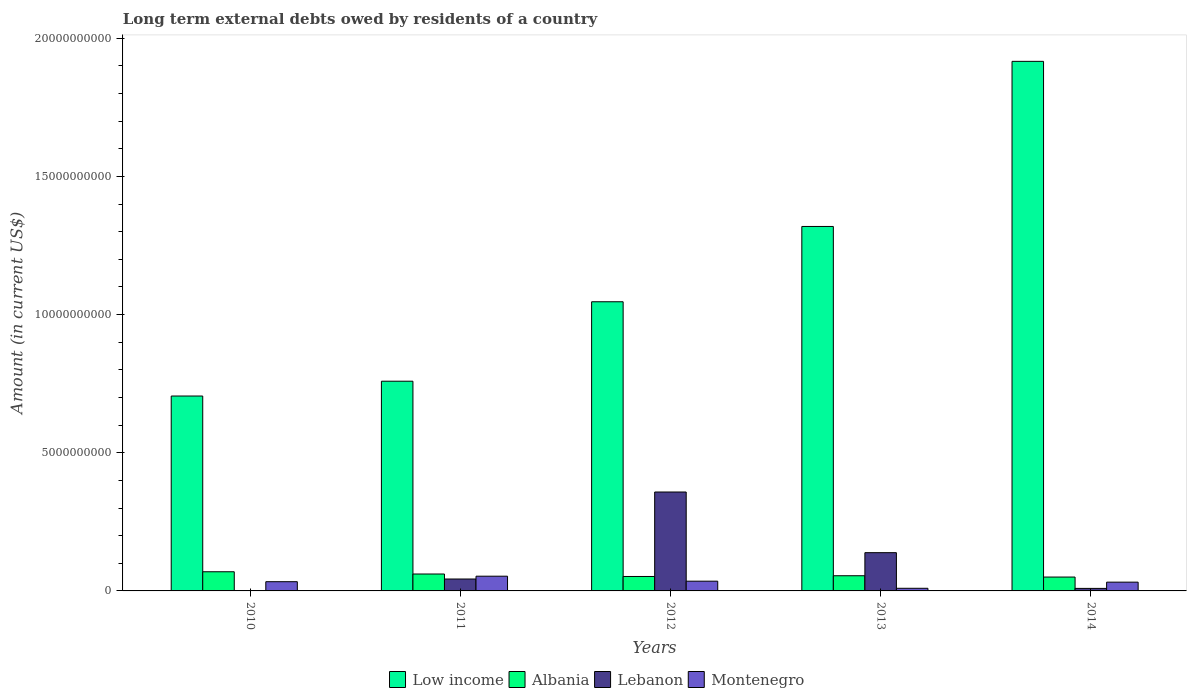How many groups of bars are there?
Provide a short and direct response. 5. How many bars are there on the 2nd tick from the right?
Give a very brief answer. 4. In how many cases, is the number of bars for a given year not equal to the number of legend labels?
Your response must be concise. 1. What is the amount of long-term external debts owed by residents in Albania in 2012?
Offer a terse response. 5.23e+08. Across all years, what is the maximum amount of long-term external debts owed by residents in Albania?
Make the answer very short. 6.93e+08. Across all years, what is the minimum amount of long-term external debts owed by residents in Montenegro?
Your response must be concise. 9.51e+07. In which year was the amount of long-term external debts owed by residents in Albania maximum?
Your answer should be compact. 2010. What is the total amount of long-term external debts owed by residents in Low income in the graph?
Offer a terse response. 5.75e+1. What is the difference between the amount of long-term external debts owed by residents in Albania in 2011 and that in 2013?
Ensure brevity in your answer.  6.29e+07. What is the difference between the amount of long-term external debts owed by residents in Low income in 2011 and the amount of long-term external debts owed by residents in Albania in 2013?
Your answer should be compact. 7.04e+09. What is the average amount of long-term external debts owed by residents in Montenegro per year?
Your response must be concise. 3.26e+08. In the year 2014, what is the difference between the amount of long-term external debts owed by residents in Low income and amount of long-term external debts owed by residents in Lebanon?
Provide a succinct answer. 1.91e+1. What is the ratio of the amount of long-term external debts owed by residents in Low income in 2010 to that in 2012?
Offer a very short reply. 0.67. Is the amount of long-term external debts owed by residents in Low income in 2011 less than that in 2014?
Give a very brief answer. Yes. Is the difference between the amount of long-term external debts owed by residents in Low income in 2011 and 2014 greater than the difference between the amount of long-term external debts owed by residents in Lebanon in 2011 and 2014?
Make the answer very short. No. What is the difference between the highest and the second highest amount of long-term external debts owed by residents in Low income?
Give a very brief answer. 5.97e+09. What is the difference between the highest and the lowest amount of long-term external debts owed by residents in Low income?
Provide a succinct answer. 1.21e+1. Is the sum of the amount of long-term external debts owed by residents in Albania in 2011 and 2013 greater than the maximum amount of long-term external debts owed by residents in Montenegro across all years?
Provide a short and direct response. Yes. Is it the case that in every year, the sum of the amount of long-term external debts owed by residents in Low income and amount of long-term external debts owed by residents in Lebanon is greater than the sum of amount of long-term external debts owed by residents in Albania and amount of long-term external debts owed by residents in Montenegro?
Ensure brevity in your answer.  Yes. Is it the case that in every year, the sum of the amount of long-term external debts owed by residents in Montenegro and amount of long-term external debts owed by residents in Albania is greater than the amount of long-term external debts owed by residents in Low income?
Your answer should be very brief. No. Are all the bars in the graph horizontal?
Offer a very short reply. No. What is the difference between two consecutive major ticks on the Y-axis?
Give a very brief answer. 5.00e+09. Does the graph contain any zero values?
Provide a succinct answer. Yes. Where does the legend appear in the graph?
Provide a short and direct response. Bottom center. How are the legend labels stacked?
Keep it short and to the point. Horizontal. What is the title of the graph?
Offer a terse response. Long term external debts owed by residents of a country. Does "Iran" appear as one of the legend labels in the graph?
Your answer should be compact. No. What is the label or title of the X-axis?
Provide a succinct answer. Years. What is the label or title of the Y-axis?
Your answer should be compact. Amount (in current US$). What is the Amount (in current US$) in Low income in 2010?
Provide a succinct answer. 7.05e+09. What is the Amount (in current US$) of Albania in 2010?
Give a very brief answer. 6.93e+08. What is the Amount (in current US$) of Montenegro in 2010?
Give a very brief answer. 3.34e+08. What is the Amount (in current US$) of Low income in 2011?
Offer a terse response. 7.59e+09. What is the Amount (in current US$) of Albania in 2011?
Offer a terse response. 6.12e+08. What is the Amount (in current US$) in Lebanon in 2011?
Your response must be concise. 4.31e+08. What is the Amount (in current US$) of Montenegro in 2011?
Give a very brief answer. 5.33e+08. What is the Amount (in current US$) of Low income in 2012?
Your response must be concise. 1.05e+1. What is the Amount (in current US$) of Albania in 2012?
Offer a terse response. 5.23e+08. What is the Amount (in current US$) of Lebanon in 2012?
Provide a succinct answer. 3.58e+09. What is the Amount (in current US$) in Montenegro in 2012?
Offer a terse response. 3.52e+08. What is the Amount (in current US$) in Low income in 2013?
Offer a very short reply. 1.32e+1. What is the Amount (in current US$) in Albania in 2013?
Your response must be concise. 5.49e+08. What is the Amount (in current US$) of Lebanon in 2013?
Your answer should be very brief. 1.38e+09. What is the Amount (in current US$) in Montenegro in 2013?
Your answer should be compact. 9.51e+07. What is the Amount (in current US$) in Low income in 2014?
Your answer should be very brief. 1.92e+1. What is the Amount (in current US$) of Albania in 2014?
Make the answer very short. 5.02e+08. What is the Amount (in current US$) in Lebanon in 2014?
Offer a terse response. 9.15e+07. What is the Amount (in current US$) in Montenegro in 2014?
Keep it short and to the point. 3.17e+08. Across all years, what is the maximum Amount (in current US$) of Low income?
Your answer should be compact. 1.92e+1. Across all years, what is the maximum Amount (in current US$) of Albania?
Make the answer very short. 6.93e+08. Across all years, what is the maximum Amount (in current US$) of Lebanon?
Offer a terse response. 3.58e+09. Across all years, what is the maximum Amount (in current US$) of Montenegro?
Your answer should be very brief. 5.33e+08. Across all years, what is the minimum Amount (in current US$) of Low income?
Ensure brevity in your answer.  7.05e+09. Across all years, what is the minimum Amount (in current US$) of Albania?
Ensure brevity in your answer.  5.02e+08. Across all years, what is the minimum Amount (in current US$) of Montenegro?
Your response must be concise. 9.51e+07. What is the total Amount (in current US$) of Low income in the graph?
Your answer should be compact. 5.75e+1. What is the total Amount (in current US$) in Albania in the graph?
Your answer should be compact. 2.88e+09. What is the total Amount (in current US$) in Lebanon in the graph?
Provide a succinct answer. 5.49e+09. What is the total Amount (in current US$) of Montenegro in the graph?
Ensure brevity in your answer.  1.63e+09. What is the difference between the Amount (in current US$) of Low income in 2010 and that in 2011?
Provide a succinct answer. -5.36e+08. What is the difference between the Amount (in current US$) of Albania in 2010 and that in 2011?
Make the answer very short. 8.15e+07. What is the difference between the Amount (in current US$) of Montenegro in 2010 and that in 2011?
Offer a terse response. -1.99e+08. What is the difference between the Amount (in current US$) of Low income in 2010 and that in 2012?
Your answer should be very brief. -3.41e+09. What is the difference between the Amount (in current US$) in Albania in 2010 and that in 2012?
Provide a succinct answer. 1.71e+08. What is the difference between the Amount (in current US$) of Montenegro in 2010 and that in 2012?
Keep it short and to the point. -1.85e+07. What is the difference between the Amount (in current US$) of Low income in 2010 and that in 2013?
Offer a very short reply. -6.14e+09. What is the difference between the Amount (in current US$) of Albania in 2010 and that in 2013?
Make the answer very short. 1.44e+08. What is the difference between the Amount (in current US$) in Montenegro in 2010 and that in 2013?
Make the answer very short. 2.39e+08. What is the difference between the Amount (in current US$) in Low income in 2010 and that in 2014?
Your answer should be compact. -1.21e+1. What is the difference between the Amount (in current US$) in Albania in 2010 and that in 2014?
Make the answer very short. 1.92e+08. What is the difference between the Amount (in current US$) in Montenegro in 2010 and that in 2014?
Provide a short and direct response. 1.67e+07. What is the difference between the Amount (in current US$) of Low income in 2011 and that in 2012?
Keep it short and to the point. -2.88e+09. What is the difference between the Amount (in current US$) in Albania in 2011 and that in 2012?
Offer a terse response. 8.91e+07. What is the difference between the Amount (in current US$) in Lebanon in 2011 and that in 2012?
Offer a terse response. -3.15e+09. What is the difference between the Amount (in current US$) in Montenegro in 2011 and that in 2012?
Give a very brief answer. 1.80e+08. What is the difference between the Amount (in current US$) of Low income in 2011 and that in 2013?
Your answer should be compact. -5.60e+09. What is the difference between the Amount (in current US$) in Albania in 2011 and that in 2013?
Give a very brief answer. 6.29e+07. What is the difference between the Amount (in current US$) in Lebanon in 2011 and that in 2013?
Provide a short and direct response. -9.53e+08. What is the difference between the Amount (in current US$) in Montenegro in 2011 and that in 2013?
Provide a short and direct response. 4.38e+08. What is the difference between the Amount (in current US$) in Low income in 2011 and that in 2014?
Your answer should be compact. -1.16e+1. What is the difference between the Amount (in current US$) of Albania in 2011 and that in 2014?
Keep it short and to the point. 1.10e+08. What is the difference between the Amount (in current US$) of Lebanon in 2011 and that in 2014?
Provide a succinct answer. 3.40e+08. What is the difference between the Amount (in current US$) of Montenegro in 2011 and that in 2014?
Make the answer very short. 2.16e+08. What is the difference between the Amount (in current US$) of Low income in 2012 and that in 2013?
Give a very brief answer. -2.72e+09. What is the difference between the Amount (in current US$) of Albania in 2012 and that in 2013?
Provide a short and direct response. -2.63e+07. What is the difference between the Amount (in current US$) in Lebanon in 2012 and that in 2013?
Offer a terse response. 2.20e+09. What is the difference between the Amount (in current US$) of Montenegro in 2012 and that in 2013?
Your answer should be compact. 2.57e+08. What is the difference between the Amount (in current US$) of Low income in 2012 and that in 2014?
Ensure brevity in your answer.  -8.70e+09. What is the difference between the Amount (in current US$) of Albania in 2012 and that in 2014?
Offer a very short reply. 2.08e+07. What is the difference between the Amount (in current US$) in Lebanon in 2012 and that in 2014?
Your answer should be compact. 3.49e+09. What is the difference between the Amount (in current US$) of Montenegro in 2012 and that in 2014?
Make the answer very short. 3.52e+07. What is the difference between the Amount (in current US$) in Low income in 2013 and that in 2014?
Your answer should be very brief. -5.97e+09. What is the difference between the Amount (in current US$) of Albania in 2013 and that in 2014?
Your answer should be very brief. 4.71e+07. What is the difference between the Amount (in current US$) in Lebanon in 2013 and that in 2014?
Keep it short and to the point. 1.29e+09. What is the difference between the Amount (in current US$) in Montenegro in 2013 and that in 2014?
Give a very brief answer. -2.22e+08. What is the difference between the Amount (in current US$) in Low income in 2010 and the Amount (in current US$) in Albania in 2011?
Your answer should be compact. 6.44e+09. What is the difference between the Amount (in current US$) of Low income in 2010 and the Amount (in current US$) of Lebanon in 2011?
Give a very brief answer. 6.62e+09. What is the difference between the Amount (in current US$) in Low income in 2010 and the Amount (in current US$) in Montenegro in 2011?
Your answer should be compact. 6.52e+09. What is the difference between the Amount (in current US$) of Albania in 2010 and the Amount (in current US$) of Lebanon in 2011?
Ensure brevity in your answer.  2.62e+08. What is the difference between the Amount (in current US$) in Albania in 2010 and the Amount (in current US$) in Montenegro in 2011?
Provide a short and direct response. 1.61e+08. What is the difference between the Amount (in current US$) of Low income in 2010 and the Amount (in current US$) of Albania in 2012?
Offer a very short reply. 6.53e+09. What is the difference between the Amount (in current US$) in Low income in 2010 and the Amount (in current US$) in Lebanon in 2012?
Your answer should be very brief. 3.47e+09. What is the difference between the Amount (in current US$) of Low income in 2010 and the Amount (in current US$) of Montenegro in 2012?
Keep it short and to the point. 6.70e+09. What is the difference between the Amount (in current US$) of Albania in 2010 and the Amount (in current US$) of Lebanon in 2012?
Offer a very short reply. -2.89e+09. What is the difference between the Amount (in current US$) of Albania in 2010 and the Amount (in current US$) of Montenegro in 2012?
Keep it short and to the point. 3.41e+08. What is the difference between the Amount (in current US$) of Low income in 2010 and the Amount (in current US$) of Albania in 2013?
Make the answer very short. 6.50e+09. What is the difference between the Amount (in current US$) in Low income in 2010 and the Amount (in current US$) in Lebanon in 2013?
Your response must be concise. 5.67e+09. What is the difference between the Amount (in current US$) of Low income in 2010 and the Amount (in current US$) of Montenegro in 2013?
Keep it short and to the point. 6.96e+09. What is the difference between the Amount (in current US$) of Albania in 2010 and the Amount (in current US$) of Lebanon in 2013?
Provide a short and direct response. -6.91e+08. What is the difference between the Amount (in current US$) in Albania in 2010 and the Amount (in current US$) in Montenegro in 2013?
Your answer should be compact. 5.98e+08. What is the difference between the Amount (in current US$) of Low income in 2010 and the Amount (in current US$) of Albania in 2014?
Offer a terse response. 6.55e+09. What is the difference between the Amount (in current US$) of Low income in 2010 and the Amount (in current US$) of Lebanon in 2014?
Provide a short and direct response. 6.96e+09. What is the difference between the Amount (in current US$) in Low income in 2010 and the Amount (in current US$) in Montenegro in 2014?
Give a very brief answer. 6.73e+09. What is the difference between the Amount (in current US$) in Albania in 2010 and the Amount (in current US$) in Lebanon in 2014?
Offer a very short reply. 6.02e+08. What is the difference between the Amount (in current US$) in Albania in 2010 and the Amount (in current US$) in Montenegro in 2014?
Offer a very short reply. 3.76e+08. What is the difference between the Amount (in current US$) in Low income in 2011 and the Amount (in current US$) in Albania in 2012?
Give a very brief answer. 7.07e+09. What is the difference between the Amount (in current US$) of Low income in 2011 and the Amount (in current US$) of Lebanon in 2012?
Keep it short and to the point. 4.01e+09. What is the difference between the Amount (in current US$) in Low income in 2011 and the Amount (in current US$) in Montenegro in 2012?
Give a very brief answer. 7.24e+09. What is the difference between the Amount (in current US$) of Albania in 2011 and the Amount (in current US$) of Lebanon in 2012?
Your response must be concise. -2.97e+09. What is the difference between the Amount (in current US$) in Albania in 2011 and the Amount (in current US$) in Montenegro in 2012?
Give a very brief answer. 2.59e+08. What is the difference between the Amount (in current US$) of Lebanon in 2011 and the Amount (in current US$) of Montenegro in 2012?
Your answer should be compact. 7.88e+07. What is the difference between the Amount (in current US$) of Low income in 2011 and the Amount (in current US$) of Albania in 2013?
Your answer should be very brief. 7.04e+09. What is the difference between the Amount (in current US$) of Low income in 2011 and the Amount (in current US$) of Lebanon in 2013?
Your answer should be compact. 6.20e+09. What is the difference between the Amount (in current US$) of Low income in 2011 and the Amount (in current US$) of Montenegro in 2013?
Your answer should be compact. 7.49e+09. What is the difference between the Amount (in current US$) of Albania in 2011 and the Amount (in current US$) of Lebanon in 2013?
Your answer should be compact. -7.72e+08. What is the difference between the Amount (in current US$) in Albania in 2011 and the Amount (in current US$) in Montenegro in 2013?
Your answer should be very brief. 5.17e+08. What is the difference between the Amount (in current US$) of Lebanon in 2011 and the Amount (in current US$) of Montenegro in 2013?
Provide a succinct answer. 3.36e+08. What is the difference between the Amount (in current US$) of Low income in 2011 and the Amount (in current US$) of Albania in 2014?
Ensure brevity in your answer.  7.09e+09. What is the difference between the Amount (in current US$) of Low income in 2011 and the Amount (in current US$) of Lebanon in 2014?
Keep it short and to the point. 7.50e+09. What is the difference between the Amount (in current US$) of Low income in 2011 and the Amount (in current US$) of Montenegro in 2014?
Offer a terse response. 7.27e+09. What is the difference between the Amount (in current US$) in Albania in 2011 and the Amount (in current US$) in Lebanon in 2014?
Your answer should be compact. 5.20e+08. What is the difference between the Amount (in current US$) in Albania in 2011 and the Amount (in current US$) in Montenegro in 2014?
Provide a short and direct response. 2.95e+08. What is the difference between the Amount (in current US$) in Lebanon in 2011 and the Amount (in current US$) in Montenegro in 2014?
Your answer should be very brief. 1.14e+08. What is the difference between the Amount (in current US$) in Low income in 2012 and the Amount (in current US$) in Albania in 2013?
Offer a very short reply. 9.91e+09. What is the difference between the Amount (in current US$) of Low income in 2012 and the Amount (in current US$) of Lebanon in 2013?
Keep it short and to the point. 9.08e+09. What is the difference between the Amount (in current US$) of Low income in 2012 and the Amount (in current US$) of Montenegro in 2013?
Offer a terse response. 1.04e+1. What is the difference between the Amount (in current US$) of Albania in 2012 and the Amount (in current US$) of Lebanon in 2013?
Make the answer very short. -8.61e+08. What is the difference between the Amount (in current US$) in Albania in 2012 and the Amount (in current US$) in Montenegro in 2013?
Provide a succinct answer. 4.28e+08. What is the difference between the Amount (in current US$) in Lebanon in 2012 and the Amount (in current US$) in Montenegro in 2013?
Provide a succinct answer. 3.48e+09. What is the difference between the Amount (in current US$) in Low income in 2012 and the Amount (in current US$) in Albania in 2014?
Ensure brevity in your answer.  9.96e+09. What is the difference between the Amount (in current US$) of Low income in 2012 and the Amount (in current US$) of Lebanon in 2014?
Ensure brevity in your answer.  1.04e+1. What is the difference between the Amount (in current US$) in Low income in 2012 and the Amount (in current US$) in Montenegro in 2014?
Provide a succinct answer. 1.01e+1. What is the difference between the Amount (in current US$) in Albania in 2012 and the Amount (in current US$) in Lebanon in 2014?
Offer a terse response. 4.31e+08. What is the difference between the Amount (in current US$) of Albania in 2012 and the Amount (in current US$) of Montenegro in 2014?
Offer a terse response. 2.06e+08. What is the difference between the Amount (in current US$) in Lebanon in 2012 and the Amount (in current US$) in Montenegro in 2014?
Provide a short and direct response. 3.26e+09. What is the difference between the Amount (in current US$) in Low income in 2013 and the Amount (in current US$) in Albania in 2014?
Give a very brief answer. 1.27e+1. What is the difference between the Amount (in current US$) of Low income in 2013 and the Amount (in current US$) of Lebanon in 2014?
Offer a terse response. 1.31e+1. What is the difference between the Amount (in current US$) of Low income in 2013 and the Amount (in current US$) of Montenegro in 2014?
Make the answer very short. 1.29e+1. What is the difference between the Amount (in current US$) in Albania in 2013 and the Amount (in current US$) in Lebanon in 2014?
Give a very brief answer. 4.58e+08. What is the difference between the Amount (in current US$) of Albania in 2013 and the Amount (in current US$) of Montenegro in 2014?
Your response must be concise. 2.32e+08. What is the difference between the Amount (in current US$) in Lebanon in 2013 and the Amount (in current US$) in Montenegro in 2014?
Your answer should be very brief. 1.07e+09. What is the average Amount (in current US$) of Low income per year?
Ensure brevity in your answer.  1.15e+1. What is the average Amount (in current US$) in Albania per year?
Ensure brevity in your answer.  5.76e+08. What is the average Amount (in current US$) of Lebanon per year?
Your answer should be compact. 1.10e+09. What is the average Amount (in current US$) of Montenegro per year?
Offer a very short reply. 3.26e+08. In the year 2010, what is the difference between the Amount (in current US$) of Low income and Amount (in current US$) of Albania?
Make the answer very short. 6.36e+09. In the year 2010, what is the difference between the Amount (in current US$) of Low income and Amount (in current US$) of Montenegro?
Provide a succinct answer. 6.72e+09. In the year 2010, what is the difference between the Amount (in current US$) in Albania and Amount (in current US$) in Montenegro?
Ensure brevity in your answer.  3.59e+08. In the year 2011, what is the difference between the Amount (in current US$) in Low income and Amount (in current US$) in Albania?
Keep it short and to the point. 6.98e+09. In the year 2011, what is the difference between the Amount (in current US$) in Low income and Amount (in current US$) in Lebanon?
Make the answer very short. 7.16e+09. In the year 2011, what is the difference between the Amount (in current US$) of Low income and Amount (in current US$) of Montenegro?
Keep it short and to the point. 7.06e+09. In the year 2011, what is the difference between the Amount (in current US$) of Albania and Amount (in current US$) of Lebanon?
Provide a short and direct response. 1.81e+08. In the year 2011, what is the difference between the Amount (in current US$) in Albania and Amount (in current US$) in Montenegro?
Offer a very short reply. 7.91e+07. In the year 2011, what is the difference between the Amount (in current US$) of Lebanon and Amount (in current US$) of Montenegro?
Your response must be concise. -1.02e+08. In the year 2012, what is the difference between the Amount (in current US$) of Low income and Amount (in current US$) of Albania?
Your response must be concise. 9.94e+09. In the year 2012, what is the difference between the Amount (in current US$) of Low income and Amount (in current US$) of Lebanon?
Keep it short and to the point. 6.88e+09. In the year 2012, what is the difference between the Amount (in current US$) of Low income and Amount (in current US$) of Montenegro?
Give a very brief answer. 1.01e+1. In the year 2012, what is the difference between the Amount (in current US$) in Albania and Amount (in current US$) in Lebanon?
Offer a terse response. -3.06e+09. In the year 2012, what is the difference between the Amount (in current US$) in Albania and Amount (in current US$) in Montenegro?
Your answer should be compact. 1.70e+08. In the year 2012, what is the difference between the Amount (in current US$) of Lebanon and Amount (in current US$) of Montenegro?
Give a very brief answer. 3.23e+09. In the year 2013, what is the difference between the Amount (in current US$) in Low income and Amount (in current US$) in Albania?
Your response must be concise. 1.26e+1. In the year 2013, what is the difference between the Amount (in current US$) of Low income and Amount (in current US$) of Lebanon?
Make the answer very short. 1.18e+1. In the year 2013, what is the difference between the Amount (in current US$) in Low income and Amount (in current US$) in Montenegro?
Your response must be concise. 1.31e+1. In the year 2013, what is the difference between the Amount (in current US$) in Albania and Amount (in current US$) in Lebanon?
Ensure brevity in your answer.  -8.35e+08. In the year 2013, what is the difference between the Amount (in current US$) in Albania and Amount (in current US$) in Montenegro?
Your answer should be compact. 4.54e+08. In the year 2013, what is the difference between the Amount (in current US$) in Lebanon and Amount (in current US$) in Montenegro?
Ensure brevity in your answer.  1.29e+09. In the year 2014, what is the difference between the Amount (in current US$) of Low income and Amount (in current US$) of Albania?
Provide a succinct answer. 1.87e+1. In the year 2014, what is the difference between the Amount (in current US$) in Low income and Amount (in current US$) in Lebanon?
Offer a very short reply. 1.91e+1. In the year 2014, what is the difference between the Amount (in current US$) of Low income and Amount (in current US$) of Montenegro?
Provide a short and direct response. 1.88e+1. In the year 2014, what is the difference between the Amount (in current US$) in Albania and Amount (in current US$) in Lebanon?
Make the answer very short. 4.10e+08. In the year 2014, what is the difference between the Amount (in current US$) in Albania and Amount (in current US$) in Montenegro?
Ensure brevity in your answer.  1.85e+08. In the year 2014, what is the difference between the Amount (in current US$) in Lebanon and Amount (in current US$) in Montenegro?
Your answer should be compact. -2.26e+08. What is the ratio of the Amount (in current US$) of Low income in 2010 to that in 2011?
Your answer should be very brief. 0.93. What is the ratio of the Amount (in current US$) in Albania in 2010 to that in 2011?
Your answer should be very brief. 1.13. What is the ratio of the Amount (in current US$) in Montenegro in 2010 to that in 2011?
Your response must be concise. 0.63. What is the ratio of the Amount (in current US$) in Low income in 2010 to that in 2012?
Your answer should be very brief. 0.67. What is the ratio of the Amount (in current US$) in Albania in 2010 to that in 2012?
Keep it short and to the point. 1.33. What is the ratio of the Amount (in current US$) of Montenegro in 2010 to that in 2012?
Offer a very short reply. 0.95. What is the ratio of the Amount (in current US$) of Low income in 2010 to that in 2013?
Give a very brief answer. 0.53. What is the ratio of the Amount (in current US$) of Albania in 2010 to that in 2013?
Offer a terse response. 1.26. What is the ratio of the Amount (in current US$) of Montenegro in 2010 to that in 2013?
Make the answer very short. 3.51. What is the ratio of the Amount (in current US$) in Low income in 2010 to that in 2014?
Provide a succinct answer. 0.37. What is the ratio of the Amount (in current US$) of Albania in 2010 to that in 2014?
Make the answer very short. 1.38. What is the ratio of the Amount (in current US$) in Montenegro in 2010 to that in 2014?
Your answer should be very brief. 1.05. What is the ratio of the Amount (in current US$) in Low income in 2011 to that in 2012?
Your answer should be compact. 0.73. What is the ratio of the Amount (in current US$) in Albania in 2011 to that in 2012?
Ensure brevity in your answer.  1.17. What is the ratio of the Amount (in current US$) of Lebanon in 2011 to that in 2012?
Your answer should be compact. 0.12. What is the ratio of the Amount (in current US$) of Montenegro in 2011 to that in 2012?
Offer a terse response. 1.51. What is the ratio of the Amount (in current US$) of Low income in 2011 to that in 2013?
Give a very brief answer. 0.58. What is the ratio of the Amount (in current US$) of Albania in 2011 to that in 2013?
Keep it short and to the point. 1.11. What is the ratio of the Amount (in current US$) in Lebanon in 2011 to that in 2013?
Your answer should be very brief. 0.31. What is the ratio of the Amount (in current US$) of Montenegro in 2011 to that in 2013?
Keep it short and to the point. 5.6. What is the ratio of the Amount (in current US$) of Low income in 2011 to that in 2014?
Give a very brief answer. 0.4. What is the ratio of the Amount (in current US$) in Albania in 2011 to that in 2014?
Provide a short and direct response. 1.22. What is the ratio of the Amount (in current US$) in Lebanon in 2011 to that in 2014?
Give a very brief answer. 4.71. What is the ratio of the Amount (in current US$) in Montenegro in 2011 to that in 2014?
Your answer should be very brief. 1.68. What is the ratio of the Amount (in current US$) in Low income in 2012 to that in 2013?
Make the answer very short. 0.79. What is the ratio of the Amount (in current US$) in Albania in 2012 to that in 2013?
Your answer should be very brief. 0.95. What is the ratio of the Amount (in current US$) in Lebanon in 2012 to that in 2013?
Make the answer very short. 2.59. What is the ratio of the Amount (in current US$) in Montenegro in 2012 to that in 2013?
Ensure brevity in your answer.  3.71. What is the ratio of the Amount (in current US$) in Low income in 2012 to that in 2014?
Your answer should be compact. 0.55. What is the ratio of the Amount (in current US$) of Albania in 2012 to that in 2014?
Your answer should be compact. 1.04. What is the ratio of the Amount (in current US$) of Lebanon in 2012 to that in 2014?
Your answer should be very brief. 39.1. What is the ratio of the Amount (in current US$) of Montenegro in 2012 to that in 2014?
Provide a short and direct response. 1.11. What is the ratio of the Amount (in current US$) of Low income in 2013 to that in 2014?
Offer a terse response. 0.69. What is the ratio of the Amount (in current US$) in Albania in 2013 to that in 2014?
Offer a very short reply. 1.09. What is the ratio of the Amount (in current US$) in Lebanon in 2013 to that in 2014?
Make the answer very short. 15.12. What is the ratio of the Amount (in current US$) in Montenegro in 2013 to that in 2014?
Make the answer very short. 0.3. What is the difference between the highest and the second highest Amount (in current US$) in Low income?
Make the answer very short. 5.97e+09. What is the difference between the highest and the second highest Amount (in current US$) of Albania?
Your response must be concise. 8.15e+07. What is the difference between the highest and the second highest Amount (in current US$) in Lebanon?
Provide a short and direct response. 2.20e+09. What is the difference between the highest and the second highest Amount (in current US$) in Montenegro?
Your answer should be very brief. 1.80e+08. What is the difference between the highest and the lowest Amount (in current US$) of Low income?
Your answer should be compact. 1.21e+1. What is the difference between the highest and the lowest Amount (in current US$) of Albania?
Ensure brevity in your answer.  1.92e+08. What is the difference between the highest and the lowest Amount (in current US$) in Lebanon?
Make the answer very short. 3.58e+09. What is the difference between the highest and the lowest Amount (in current US$) of Montenegro?
Provide a short and direct response. 4.38e+08. 